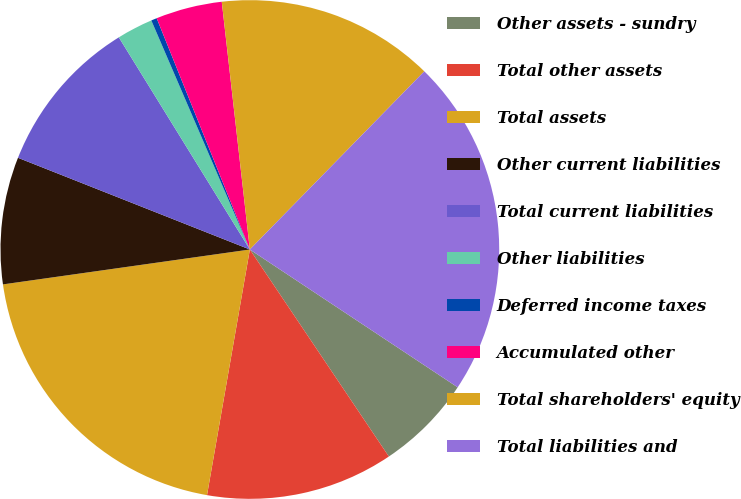Convert chart to OTSL. <chart><loc_0><loc_0><loc_500><loc_500><pie_chart><fcel>Other assets - sundry<fcel>Total other assets<fcel>Total assets<fcel>Other current liabilities<fcel>Total current liabilities<fcel>Other liabilities<fcel>Deferred income taxes<fcel>Accumulated other<fcel>Total shareholders' equity<fcel>Total liabilities and<nl><fcel>6.27%<fcel>12.16%<fcel>20.02%<fcel>8.23%<fcel>10.2%<fcel>2.34%<fcel>0.37%<fcel>4.3%<fcel>14.13%<fcel>21.99%<nl></chart> 